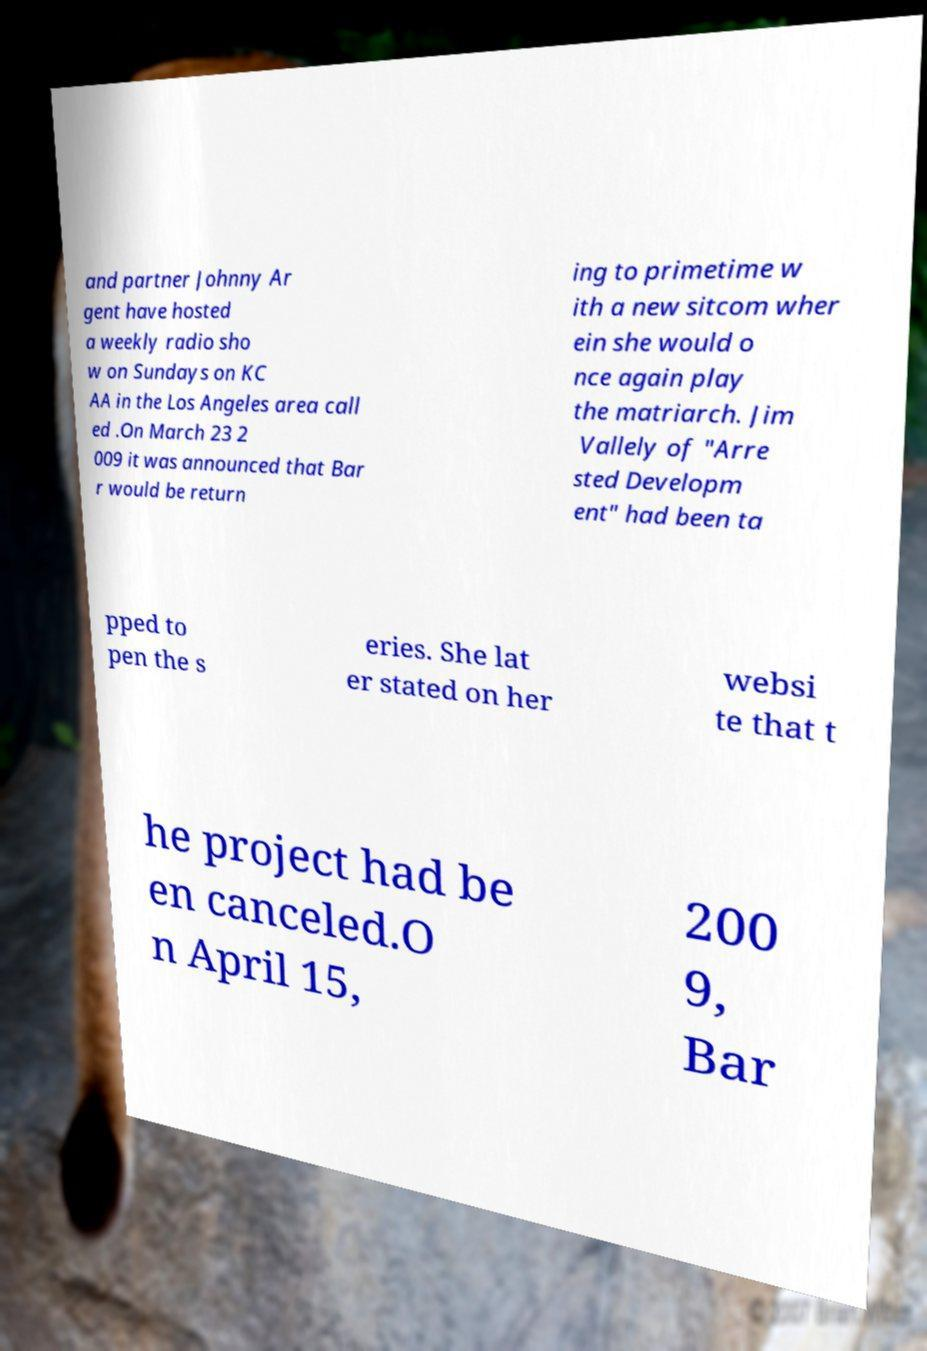Please read and relay the text visible in this image. What does it say? and partner Johnny Ar gent have hosted a weekly radio sho w on Sundays on KC AA in the Los Angeles area call ed .On March 23 2 009 it was announced that Bar r would be return ing to primetime w ith a new sitcom wher ein she would o nce again play the matriarch. Jim Vallely of "Arre sted Developm ent" had been ta pped to pen the s eries. She lat er stated on her websi te that t he project had be en canceled.O n April 15, 200 9, Bar 